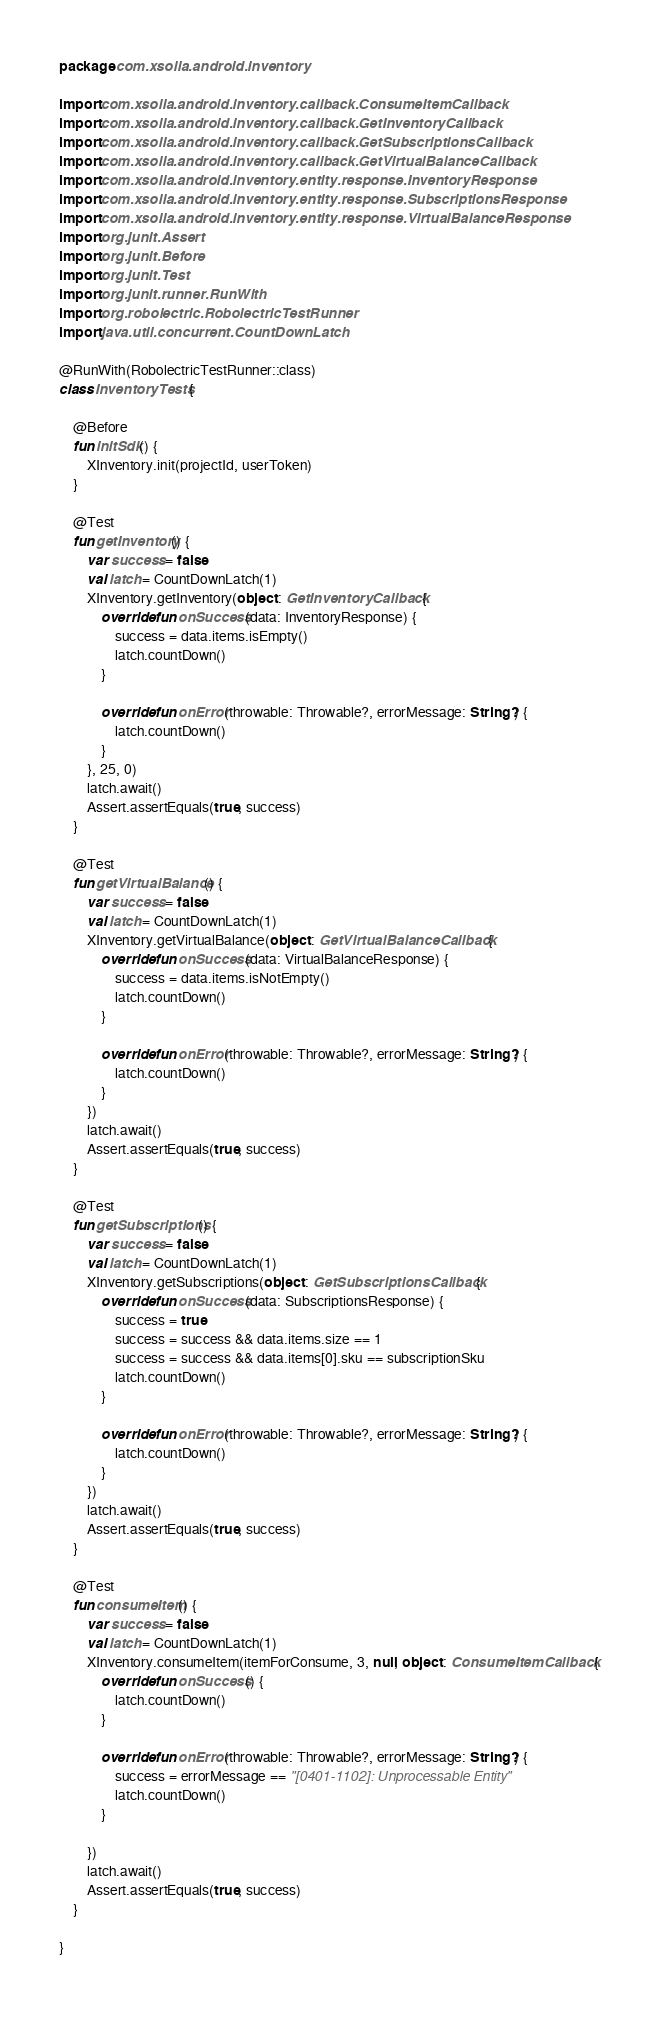Convert code to text. <code><loc_0><loc_0><loc_500><loc_500><_Kotlin_>package com.xsolla.android.inventory

import com.xsolla.android.inventory.callback.ConsumeItemCallback
import com.xsolla.android.inventory.callback.GetInventoryCallback
import com.xsolla.android.inventory.callback.GetSubscriptionsCallback
import com.xsolla.android.inventory.callback.GetVirtualBalanceCallback
import com.xsolla.android.inventory.entity.response.InventoryResponse
import com.xsolla.android.inventory.entity.response.SubscriptionsResponse
import com.xsolla.android.inventory.entity.response.VirtualBalanceResponse
import org.junit.Assert
import org.junit.Before
import org.junit.Test
import org.junit.runner.RunWith
import org.robolectric.RobolectricTestRunner
import java.util.concurrent.CountDownLatch

@RunWith(RobolectricTestRunner::class)
class InventoryTests {

    @Before
    fun initSdk() {
        XInventory.init(projectId, userToken)
    }

    @Test
    fun getInventory() {
        var success = false
        val latch = CountDownLatch(1)
        XInventory.getInventory(object : GetInventoryCallback {
            override fun onSuccess(data: InventoryResponse) {
                success = data.items.isEmpty()
                latch.countDown()
            }

            override fun onError(throwable: Throwable?, errorMessage: String?) {
                latch.countDown()
            }
        }, 25, 0)
        latch.await()
        Assert.assertEquals(true, success)
    }

    @Test
    fun getVirtualBalance() {
        var success = false
        val latch = CountDownLatch(1)
        XInventory.getVirtualBalance(object : GetVirtualBalanceCallback {
            override fun onSuccess(data: VirtualBalanceResponse) {
                success = data.items.isNotEmpty()
                latch.countDown()
            }

            override fun onError(throwable: Throwable?, errorMessage: String?) {
                latch.countDown()
            }
        })
        latch.await()
        Assert.assertEquals(true, success)
    }

    @Test
    fun getSubscriptions() {
        var success = false
        val latch = CountDownLatch(1)
        XInventory.getSubscriptions(object : GetSubscriptionsCallback {
            override fun onSuccess(data: SubscriptionsResponse) {
                success = true
                success = success && data.items.size == 1
                success = success && data.items[0].sku == subscriptionSku
                latch.countDown()
            }

            override fun onError(throwable: Throwable?, errorMessage: String?) {
                latch.countDown()
            }
        })
        latch.await()
        Assert.assertEquals(true, success)
    }

    @Test
    fun consumeItem() {
        var success = false
        val latch = CountDownLatch(1)
        XInventory.consumeItem(itemForConsume, 3, null, object : ConsumeItemCallback {
            override fun onSuccess() {
                latch.countDown()
            }

            override fun onError(throwable: Throwable?, errorMessage: String?) {
                success = errorMessage == "[0401-1102]: Unprocessable Entity"
                latch.countDown()
            }

        })
        latch.await()
        Assert.assertEquals(true, success)
    }

}</code> 